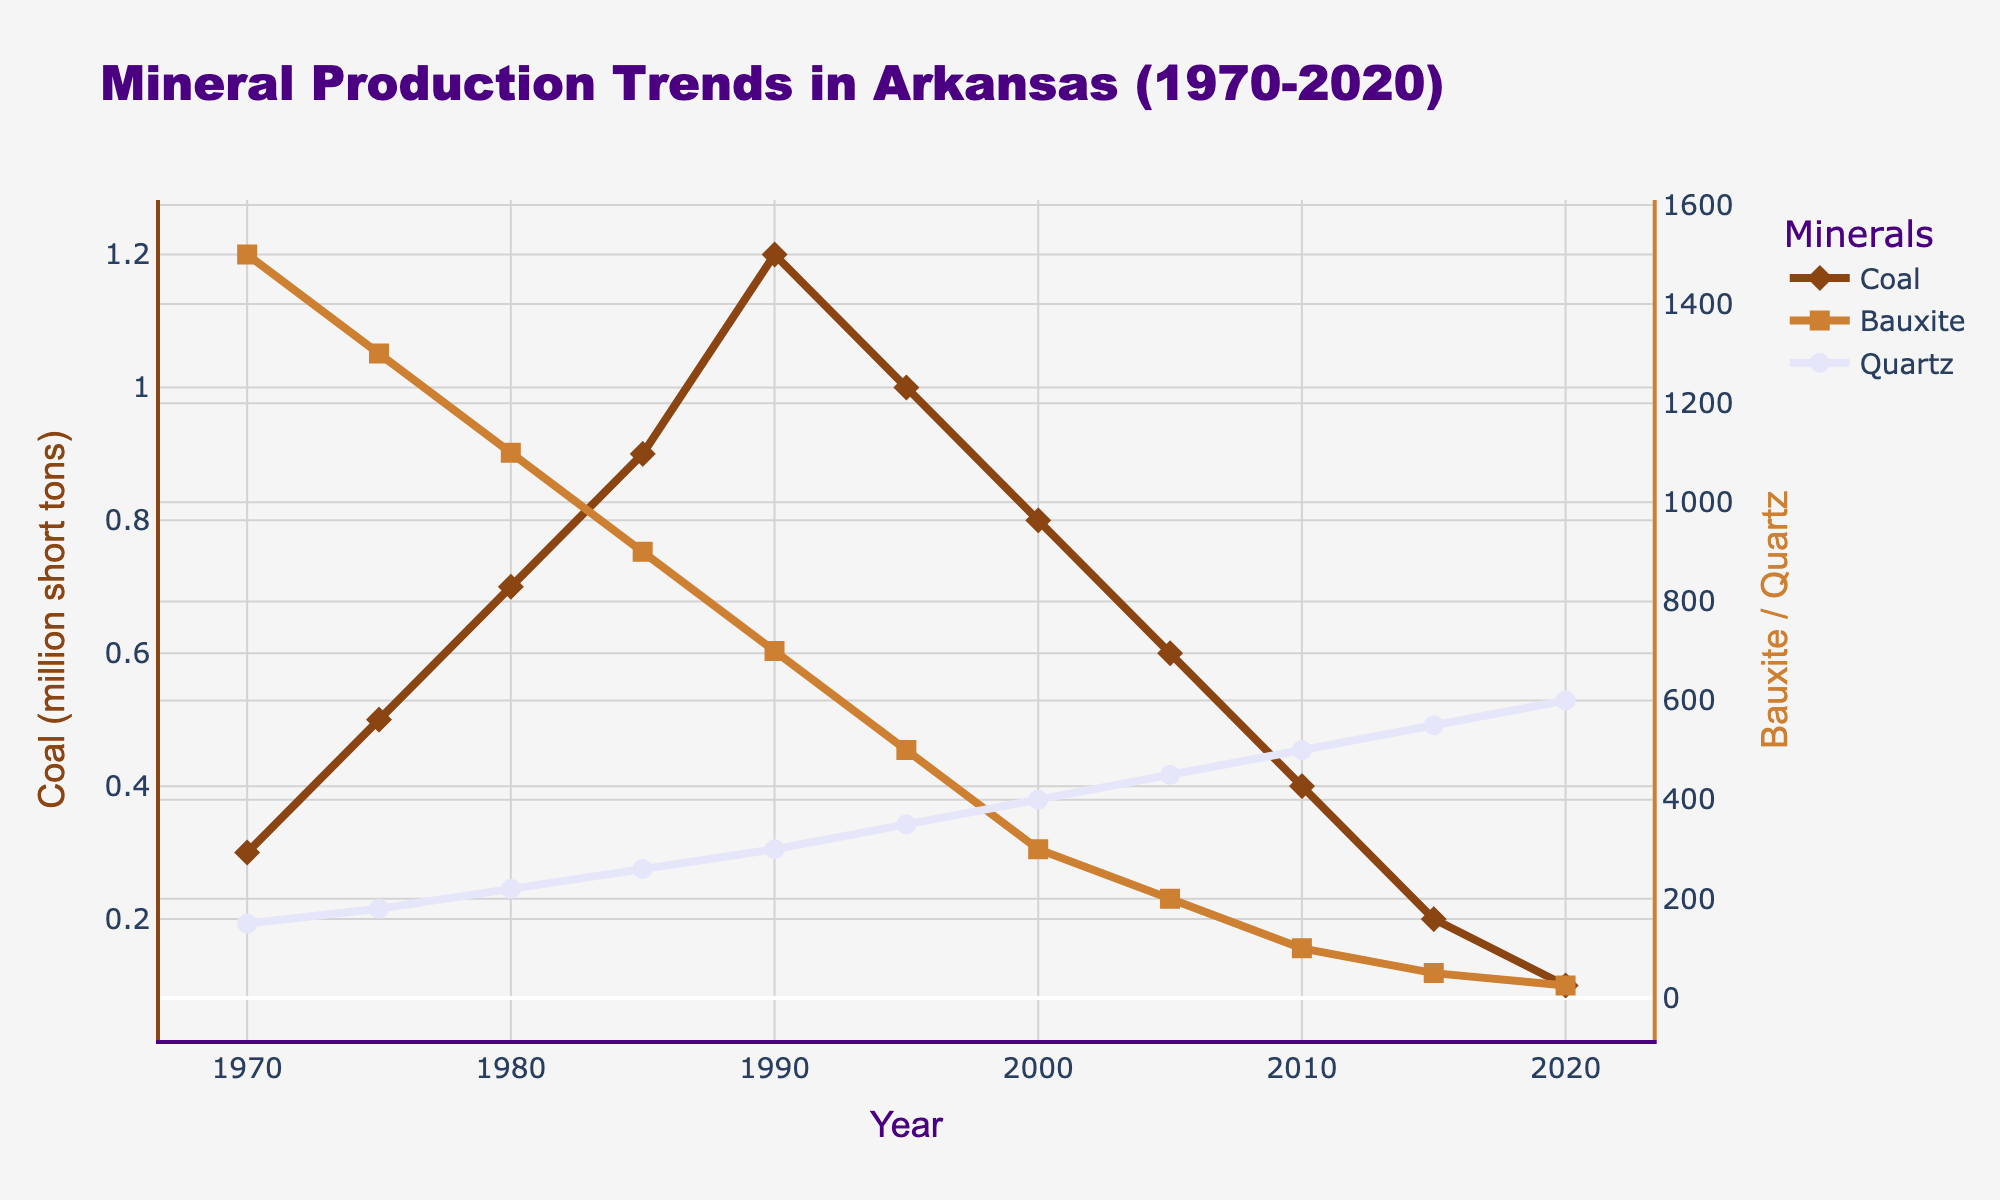Which year had the highest coal production? To find the year of the highest coal production, look at the peak value of the coal trend line. The highest peak for coal production is in 1990, which reaches 1.2 million short tons.
Answer: 1990 How did bauxite production change between 1970 and 2000? Compare the values of bauxite production at 1970 and 2000. In 1970, bauxite production was 1500 thousand metric tons, and by 2000 it decreased to 300 thousand metric tons.
Answer: Decreased by 1200 thousand metric tons Which mineral showed a continuous increase over the period? Look for the mineral whose trend line consistently goes up. Quartz production shows a continuous increase from 1970 to 2020.
Answer: Quartz What is the difference between the highest and the lowest coal production? Identify the peak and the lowest points in the coal production trend. The highest is 1.2 million short tons in 1990, and the lowest is 0.1 million short tons in 2020. The difference is 1.2 - 0.1 = 1.1 million short tons.
Answer: 1.1 million short tons In which year did bauxite production dip below 100 thousand metric tons? Look for the point at which the bauxite trend line falls below the 100 thousand metric tons mark. This occurred in 2010.
Answer: 2010 What was the quartz production in the year when coal production was the lowest? Find the quartz production corresponding to the lowest point in the coal production trend. In 2020, when coal production was lowest at 0.1 million short tons, quartz production was 600 thousand carats.
Answer: 600 thousand carats Compare bauxite and coal production in 2005. Which was higher? Identify the values of both bauxite and coal production in 2005. Bauxite production was 200 thousand metric tons, and coal production was 0.6 million short tons. Since 0.6 million short tons is higher than 200 thousand metric tons, coal production was higher.
Answer: Coal production was higher What is the overall trend of coal production from 1970 to 2020? Analyze the coal production trend line from 1970 to 2020. The coal production shows an overall declining trend from 0.3 million short tons in 1970 to 0.1 million short tons in 2020.
Answer: Decreasing Calculate the average quartz production over the 50 years. Add up all the quartz production values and divide by the number of years. (150 + 180 + 220 + 260 + 300 + 350 + 400 + 450 + 500 + 550 + 600) / 11 = 396.36 thousand carats
Answer: 396.36 thousand carats 